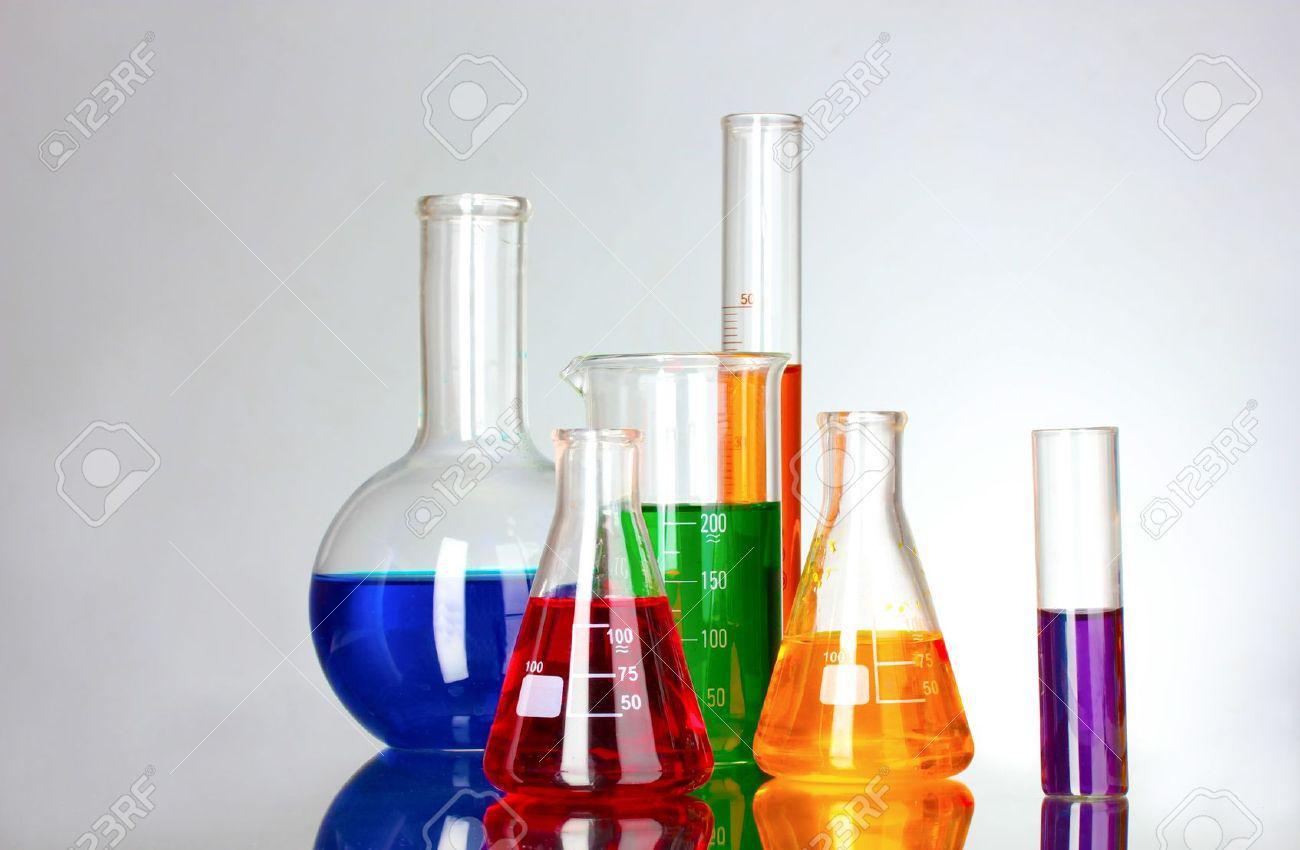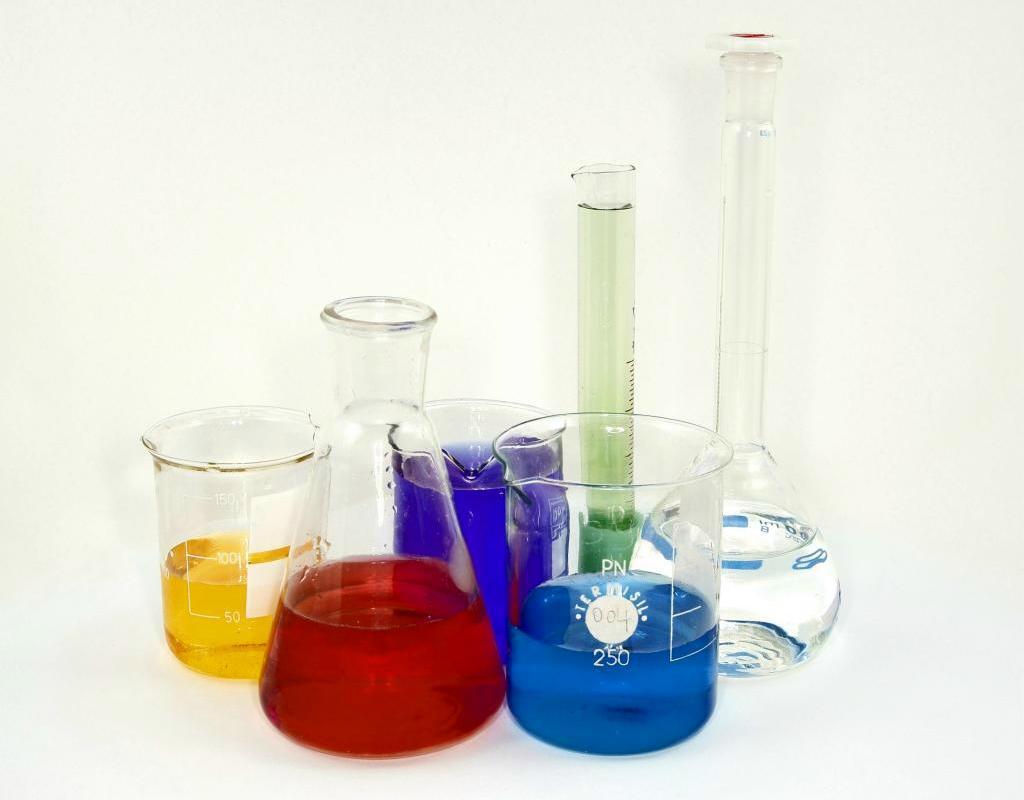The first image is the image on the left, the second image is the image on the right. Analyze the images presented: Is the assertion "One image shows exactly three containers of different colored liquids in a level row with no overlap, and one of the bottles has a round bottom and tall slender neck." valid? Answer yes or no. No. The first image is the image on the left, the second image is the image on the right. Analyze the images presented: Is the assertion "In the image on the right, the container furthest to the left contains a blue liquid." valid? Answer yes or no. No. 